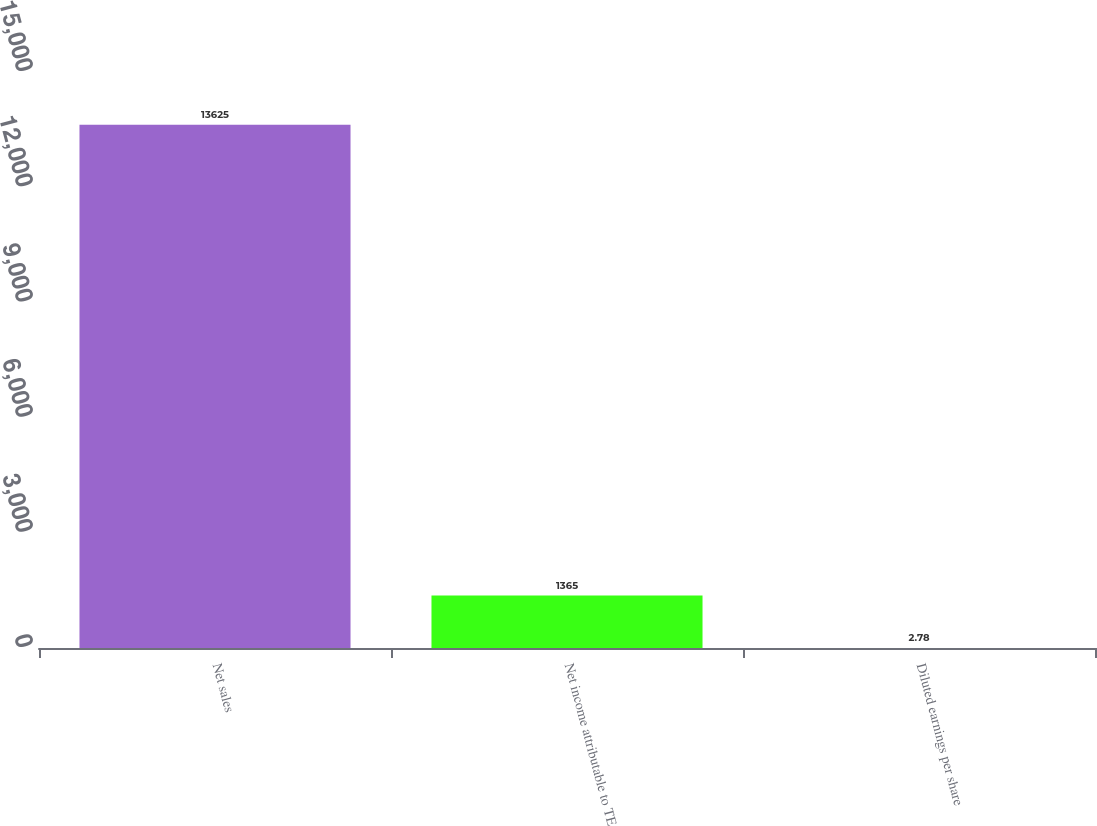Convert chart to OTSL. <chart><loc_0><loc_0><loc_500><loc_500><bar_chart><fcel>Net sales<fcel>Net income attributable to TE<fcel>Diluted earnings per share<nl><fcel>13625<fcel>1365<fcel>2.78<nl></chart> 